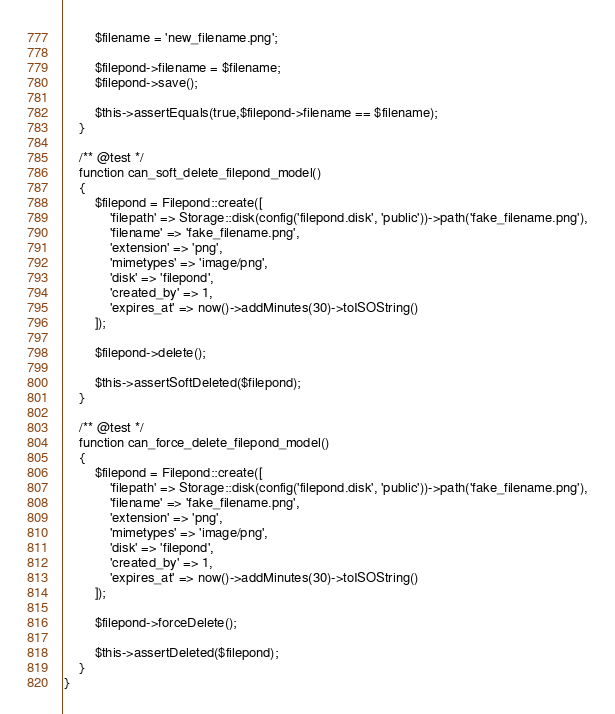<code> <loc_0><loc_0><loc_500><loc_500><_PHP_>        $filename = 'new_filename.png';

        $filepond->filename = $filename;
        $filepond->save();

        $this->assertEquals(true,$filepond->filename == $filename);
    }

    /** @test */
    function can_soft_delete_filepond_model()
    {
        $filepond = Filepond::create([
            'filepath' => Storage::disk(config('filepond.disk', 'public'))->path('fake_filename.png'),
            'filename' => 'fake_filename.png',
            'extension' => 'png',
            'mimetypes' => 'image/png',
            'disk' => 'filepond',
            'created_by' => 1,
            'expires_at' => now()->addMinutes(30)->toISOString()
        ]);

        $filepond->delete();

        $this->assertSoftDeleted($filepond);
    }

    /** @test */
    function can_force_delete_filepond_model()
    {
        $filepond = Filepond::create([
            'filepath' => Storage::disk(config('filepond.disk', 'public'))->path('fake_filename.png'),
            'filename' => 'fake_filename.png',
            'extension' => 'png',
            'mimetypes' => 'image/png',
            'disk' => 'filepond',
            'created_by' => 1,
            'expires_at' => now()->addMinutes(30)->toISOString()
        ]);

        $filepond->forceDelete();

        $this->assertDeleted($filepond);
    }
}</code> 